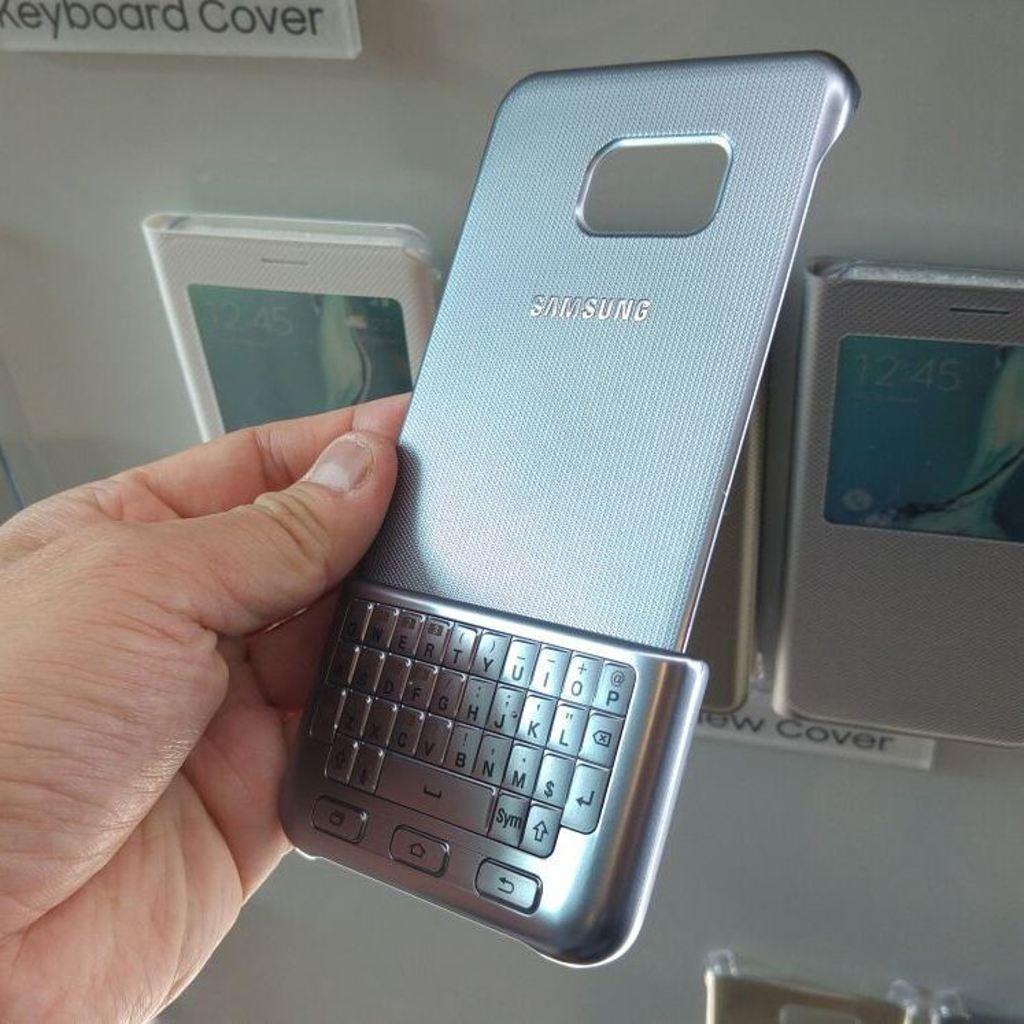Can you describe this image briefly? In this image I can see hand of a person holding a keypad and a back panel of a mobile. In the background they looks like mobile covers attached to an object. 